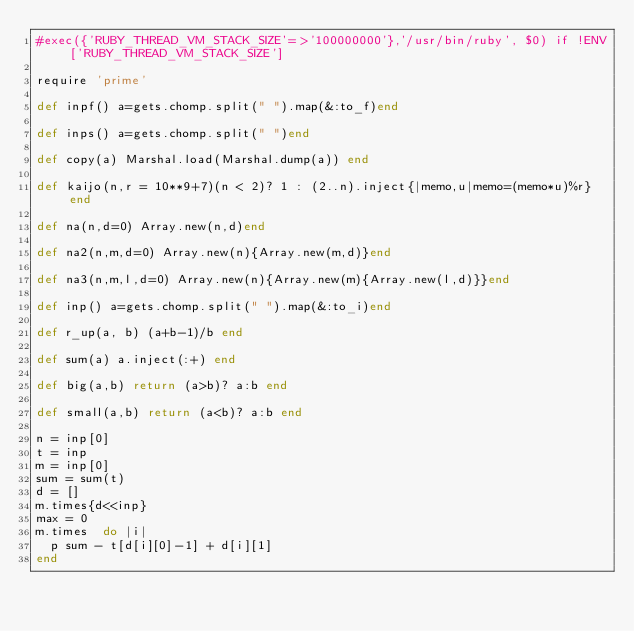<code> <loc_0><loc_0><loc_500><loc_500><_Ruby_>#exec({'RUBY_THREAD_VM_STACK_SIZE'=>'100000000'},'/usr/bin/ruby', $0) if !ENV['RUBY_THREAD_VM_STACK_SIZE']

require 'prime'

def inpf() a=gets.chomp.split(" ").map(&:to_f)end

def inps() a=gets.chomp.split(" ")end

def copy(a) Marshal.load(Marshal.dump(a)) end

def kaijo(n,r = 10**9+7)(n < 2)? 1 : (2..n).inject{|memo,u|memo=(memo*u)%r} end

def na(n,d=0) Array.new(n,d)end

def na2(n,m,d=0) Array.new(n){Array.new(m,d)}end

def na3(n,m,l,d=0) Array.new(n){Array.new(m){Array.new(l,d)}}end

def inp() a=gets.chomp.split(" ").map(&:to_i)end

def r_up(a, b) (a+b-1)/b end

def sum(a) a.inject(:+) end

def big(a,b) return (a>b)? a:b end

def small(a,b) return (a<b)? a:b end

n = inp[0]
t = inp
m = inp[0]
sum = sum(t)
d = []
m.times{d<<inp}
max = 0
m.times  do |i|
  p sum - t[d[i][0]-1] + d[i][1]
end</code> 